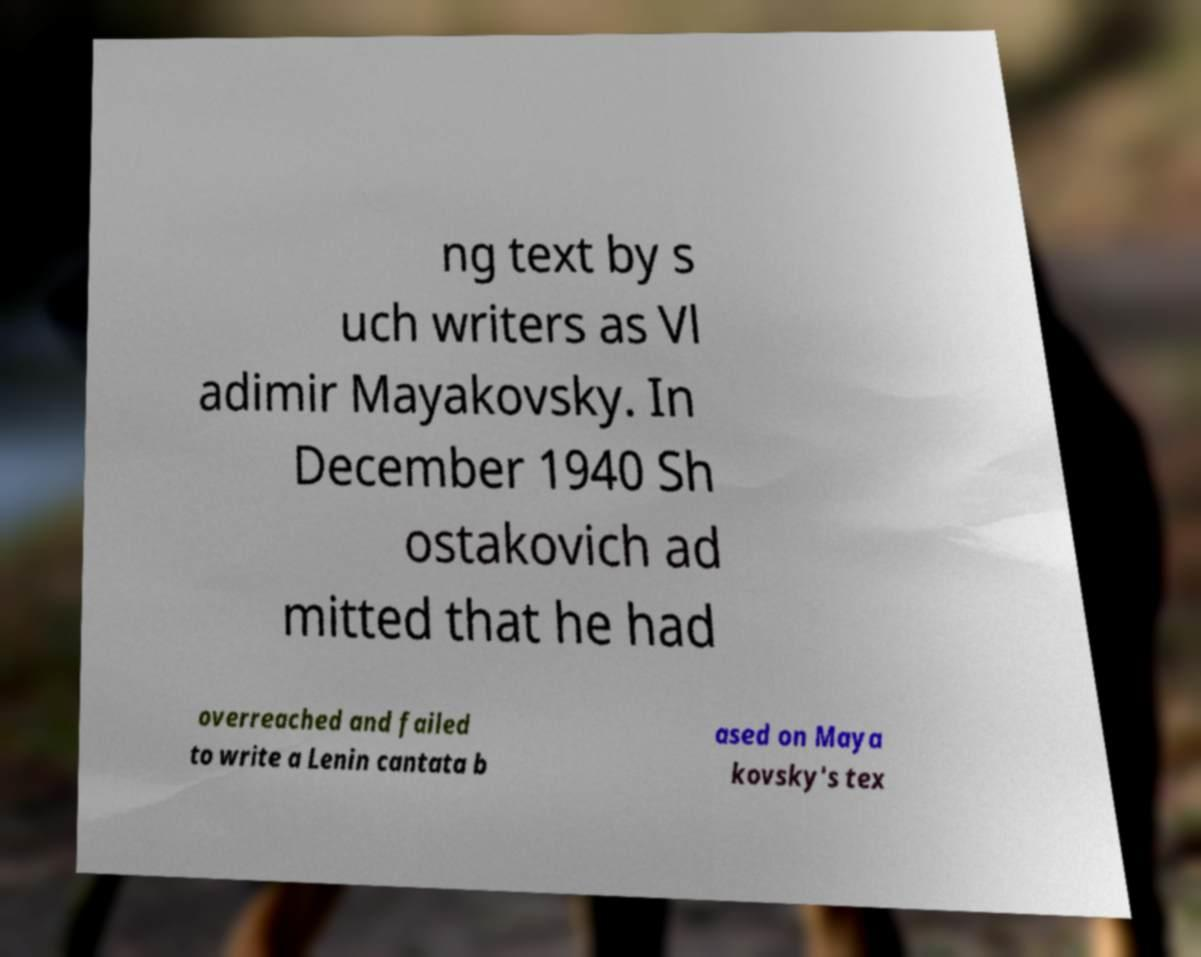I need the written content from this picture converted into text. Can you do that? ng text by s uch writers as Vl adimir Mayakovsky. In December 1940 Sh ostakovich ad mitted that he had overreached and failed to write a Lenin cantata b ased on Maya kovsky's tex 